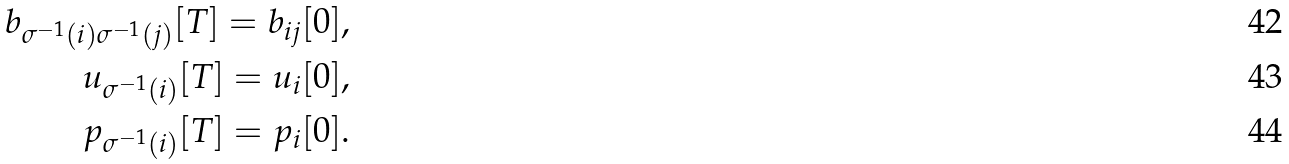<formula> <loc_0><loc_0><loc_500><loc_500>b _ { \sigma ^ { - 1 } ( i ) \sigma ^ { - 1 } ( j ) } [ T ] = b _ { i j } [ 0 ] , \\ u _ { \sigma ^ { - 1 } ( i ) } [ T ] = u _ { i } [ 0 ] , \\ p _ { \sigma ^ { - 1 } ( i ) } [ T ] = p _ { i } [ 0 ] .</formula> 